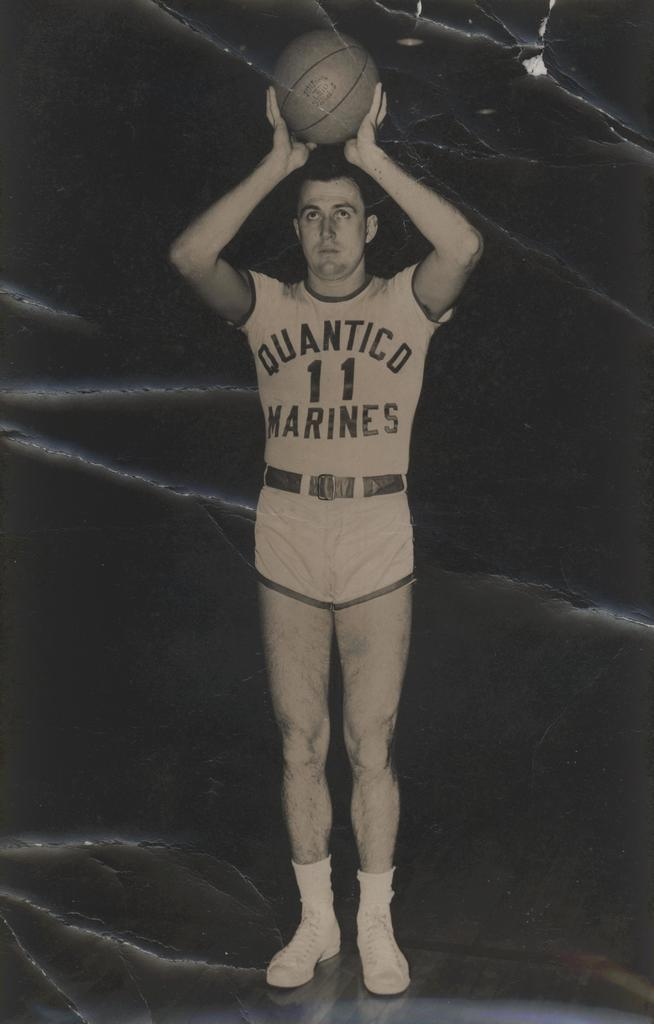<image>
Provide a brief description of the given image. A tall, Caucasian man is on a poster, holding a basketball over his head, in a white Quantico Marines, basketball uniform from many years ago . 